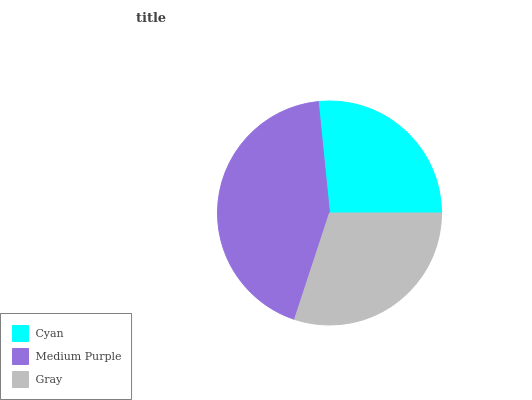Is Cyan the minimum?
Answer yes or no. Yes. Is Medium Purple the maximum?
Answer yes or no. Yes. Is Gray the minimum?
Answer yes or no. No. Is Gray the maximum?
Answer yes or no. No. Is Medium Purple greater than Gray?
Answer yes or no. Yes. Is Gray less than Medium Purple?
Answer yes or no. Yes. Is Gray greater than Medium Purple?
Answer yes or no. No. Is Medium Purple less than Gray?
Answer yes or no. No. Is Gray the high median?
Answer yes or no. Yes. Is Gray the low median?
Answer yes or no. Yes. Is Cyan the high median?
Answer yes or no. No. Is Cyan the low median?
Answer yes or no. No. 